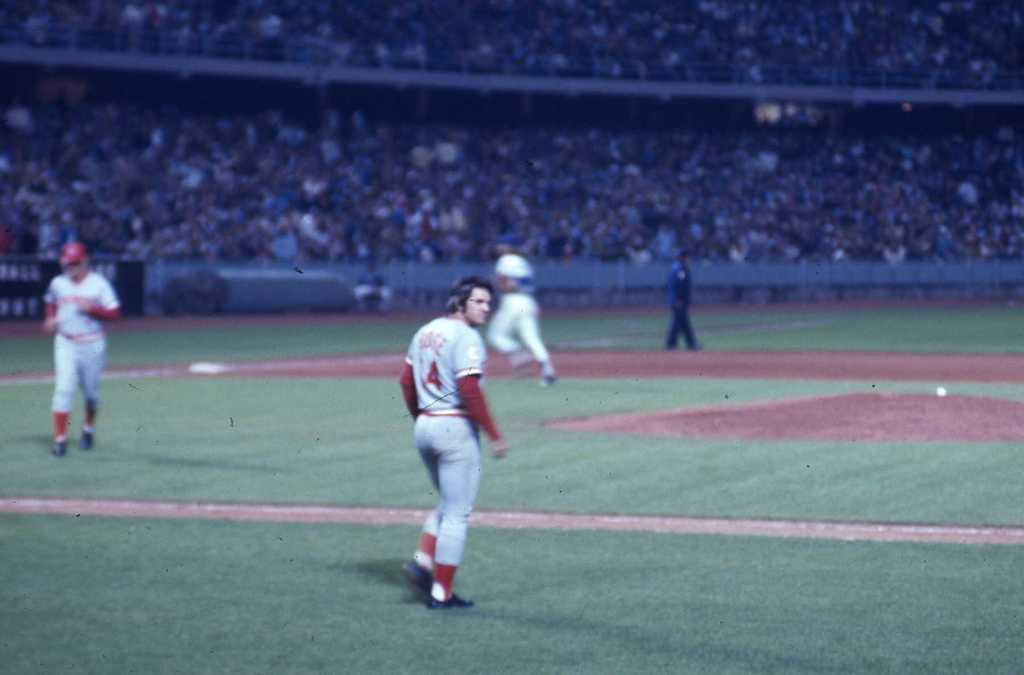<image>
Share a concise interpretation of the image provided. Pate Rose standing on the field with the number 4 